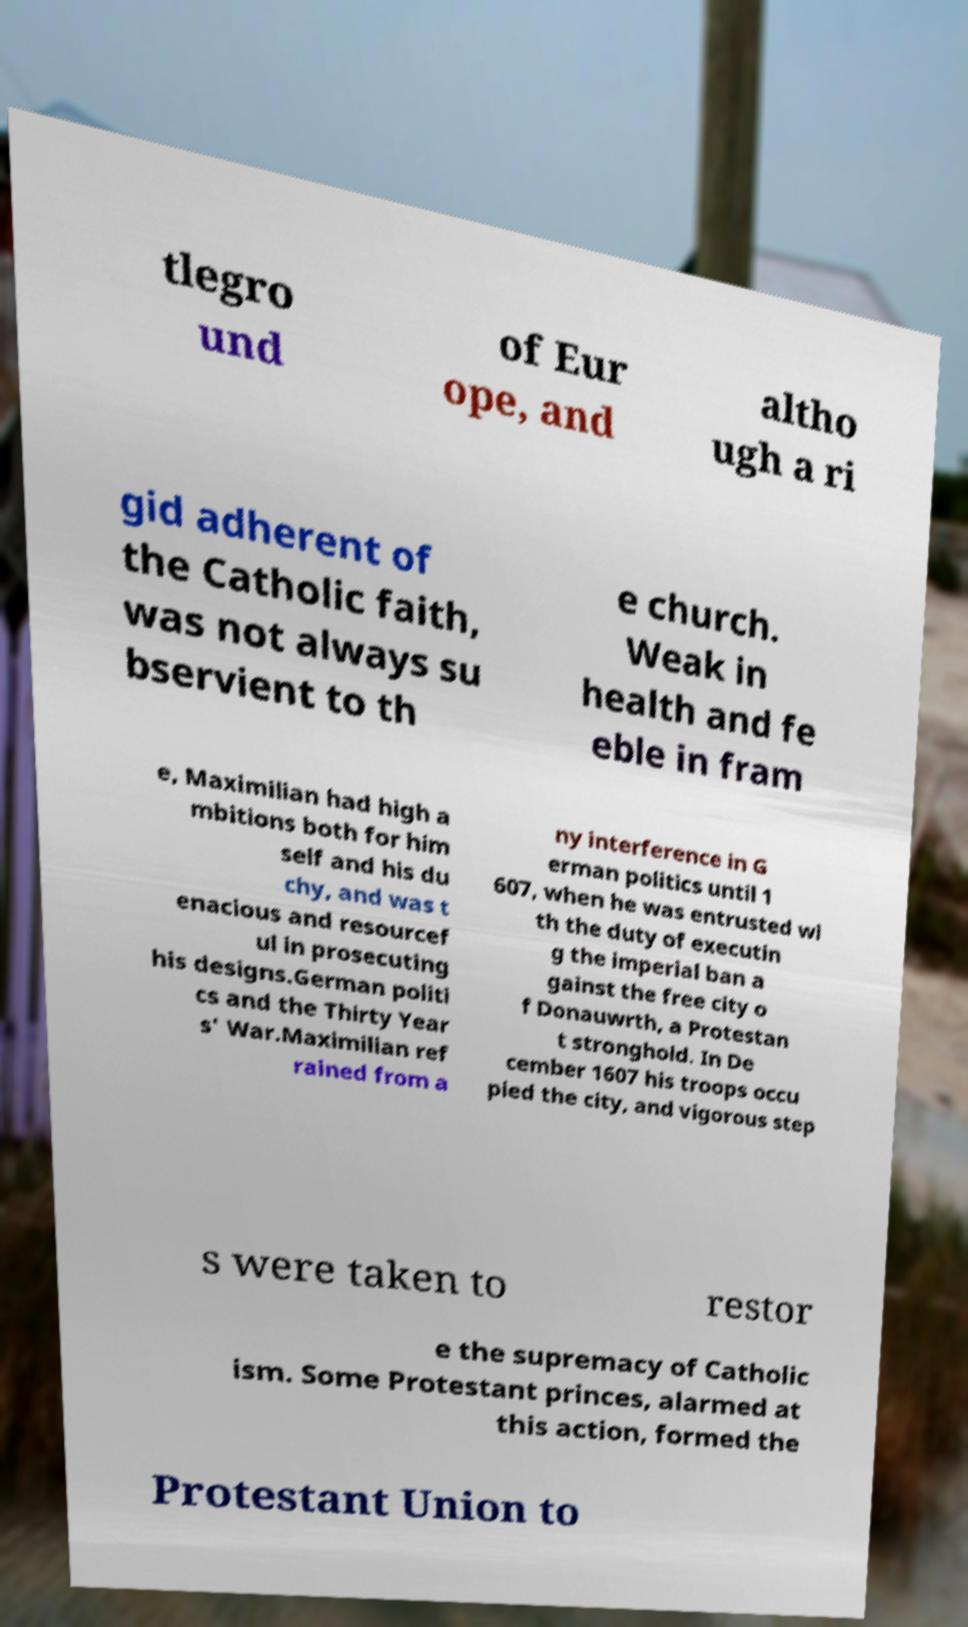I need the written content from this picture converted into text. Can you do that? tlegro und of Eur ope, and altho ugh a ri gid adherent of the Catholic faith, was not always su bservient to th e church. Weak in health and fe eble in fram e, Maximilian had high a mbitions both for him self and his du chy, and was t enacious and resourcef ul in prosecuting his designs.German politi cs and the Thirty Year s' War.Maximilian ref rained from a ny interference in G erman politics until 1 607, when he was entrusted wi th the duty of executin g the imperial ban a gainst the free city o f Donauwrth, a Protestan t stronghold. In De cember 1607 his troops occu pied the city, and vigorous step s were taken to restor e the supremacy of Catholic ism. Some Protestant princes, alarmed at this action, formed the Protestant Union to 